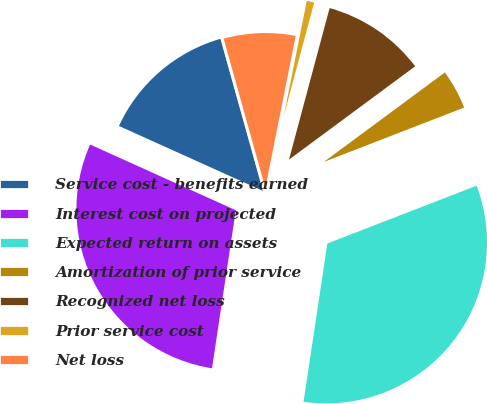<chart> <loc_0><loc_0><loc_500><loc_500><pie_chart><fcel>Service cost - benefits earned<fcel>Interest cost on projected<fcel>Expected return on assets<fcel>Amortization of prior service<fcel>Recognized net loss<fcel>Prior service cost<fcel>Net loss<nl><fcel>13.92%<fcel>29.37%<fcel>33.26%<fcel>4.25%<fcel>10.7%<fcel>1.03%<fcel>7.47%<nl></chart> 